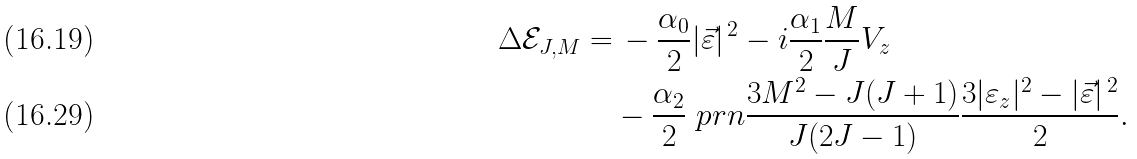Convert formula to latex. <formula><loc_0><loc_0><loc_500><loc_500>\Delta \mathcal { E } _ { J , M } = & \, - \frac { \alpha _ { 0 } } { 2 } | \vec { \varepsilon } | ^ { \, 2 } - i \frac { \alpha _ { 1 } } { 2 } \frac { M } { J } V _ { z } \\ & - \frac { \alpha _ { 2 } } { 2 } \ p r n { \frac { 3 M ^ { 2 } - J ( J + 1 ) } { J ( 2 J - 1 ) } } \frac { 3 | \varepsilon _ { z } | ^ { 2 } - | \vec { \varepsilon } | ^ { \, 2 } } { 2 } .</formula> 